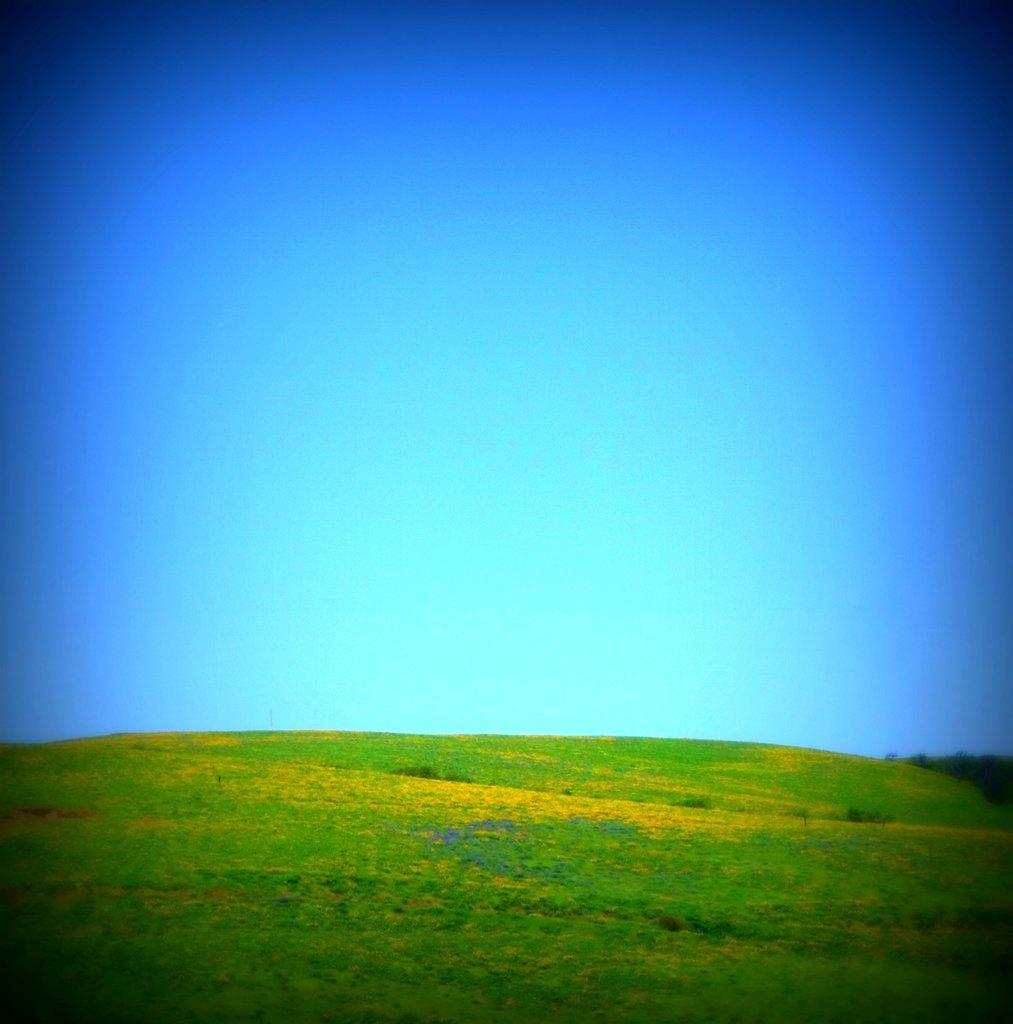What type of vegetation can be seen in the image? There is grass in the image. What part of the natural environment is visible in the image? The sky is visible in the image. How would you describe the color of the sky in the image? The color of the sky is described as beautiful blue. Can you see a dog touching the grass in the image? There is no dog present in the image, and therefore no interaction with the grass can be observed. Is there a zoo visible in the image? There is no zoo present in the image; it only features grass and a beautiful blue sky. 